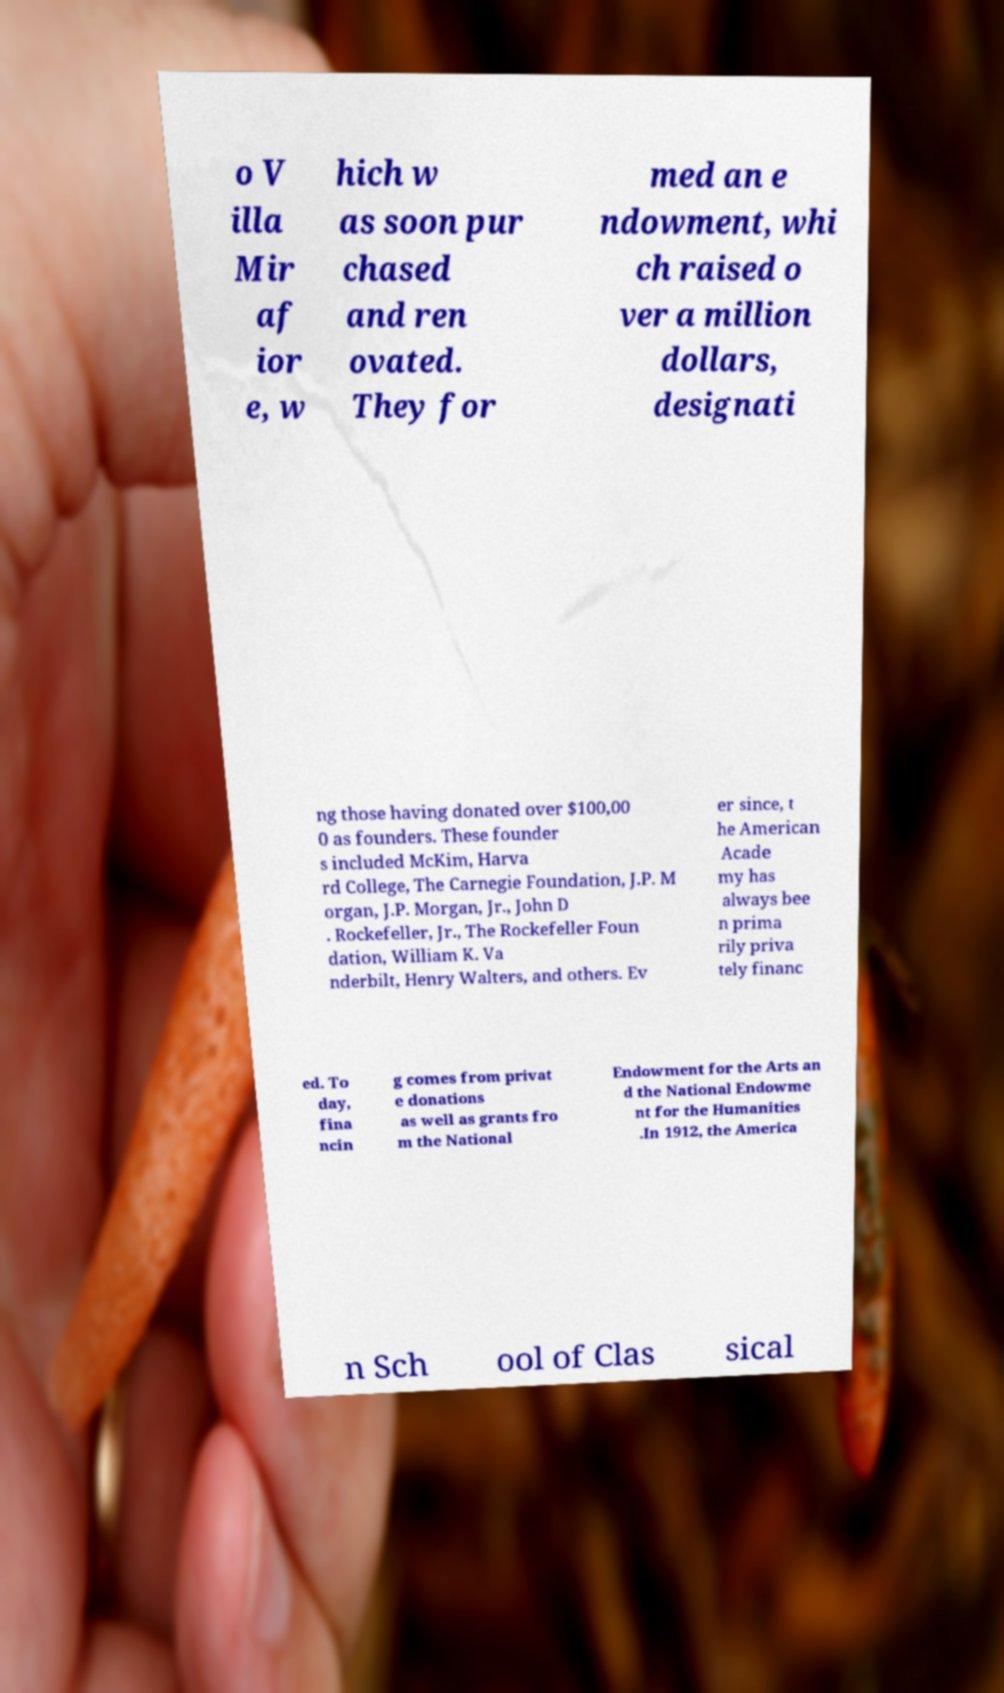Could you assist in decoding the text presented in this image and type it out clearly? o V illa Mir af ior e, w hich w as soon pur chased and ren ovated. They for med an e ndowment, whi ch raised o ver a million dollars, designati ng those having donated over $100,00 0 as founders. These founder s included McKim, Harva rd College, The Carnegie Foundation, J.P. M organ, J.P. Morgan, Jr., John D . Rockefeller, Jr., The Rockefeller Foun dation, William K. Va nderbilt, Henry Walters, and others. Ev er since, t he American Acade my has always bee n prima rily priva tely financ ed. To day, fina ncin g comes from privat e donations as well as grants fro m the National Endowment for the Arts an d the National Endowme nt for the Humanities .In 1912, the America n Sch ool of Clas sical 